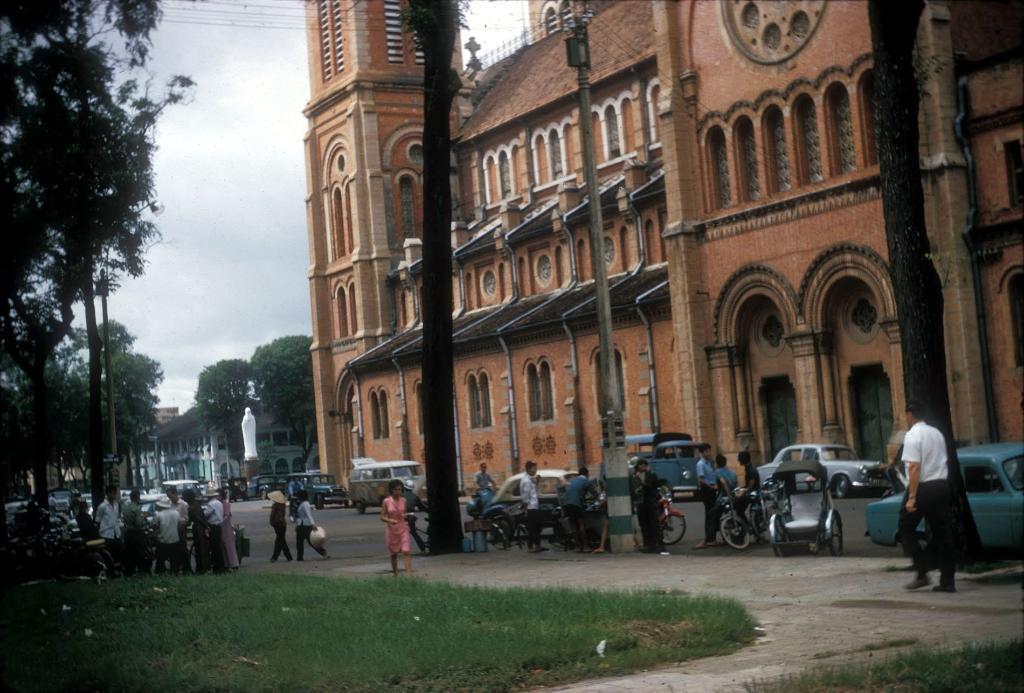How would you summarize this image in a sentence or two? In the center of the image there are buildings. At the bottom we can see people standing and some of them are walking. There are cars, vans and bicycles on the road. In the background there are trees, pole, statue and sky. 